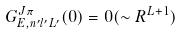<formula> <loc_0><loc_0><loc_500><loc_500>G _ { E , n ^ { \prime } l ^ { \prime } L ^ { \prime } } ^ { J \pi } ( 0 ) = 0 ( \sim R ^ { L + 1 } )</formula> 